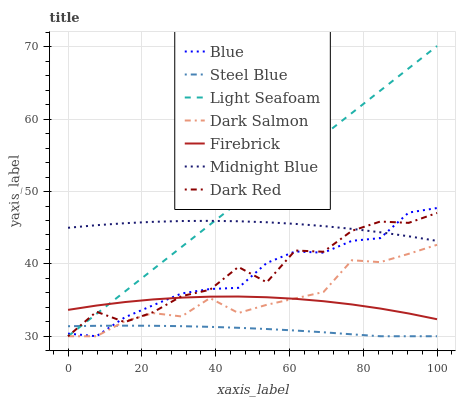Does Steel Blue have the minimum area under the curve?
Answer yes or no. Yes. Does Light Seafoam have the maximum area under the curve?
Answer yes or no. Yes. Does Midnight Blue have the minimum area under the curve?
Answer yes or no. No. Does Midnight Blue have the maximum area under the curve?
Answer yes or no. No. Is Light Seafoam the smoothest?
Answer yes or no. Yes. Is Dark Red the roughest?
Answer yes or no. Yes. Is Midnight Blue the smoothest?
Answer yes or no. No. Is Midnight Blue the roughest?
Answer yes or no. No. Does Blue have the lowest value?
Answer yes or no. Yes. Does Midnight Blue have the lowest value?
Answer yes or no. No. Does Light Seafoam have the highest value?
Answer yes or no. Yes. Does Midnight Blue have the highest value?
Answer yes or no. No. Is Steel Blue less than Midnight Blue?
Answer yes or no. Yes. Is Midnight Blue greater than Dark Salmon?
Answer yes or no. Yes. Does Midnight Blue intersect Dark Red?
Answer yes or no. Yes. Is Midnight Blue less than Dark Red?
Answer yes or no. No. Is Midnight Blue greater than Dark Red?
Answer yes or no. No. Does Steel Blue intersect Midnight Blue?
Answer yes or no. No. 